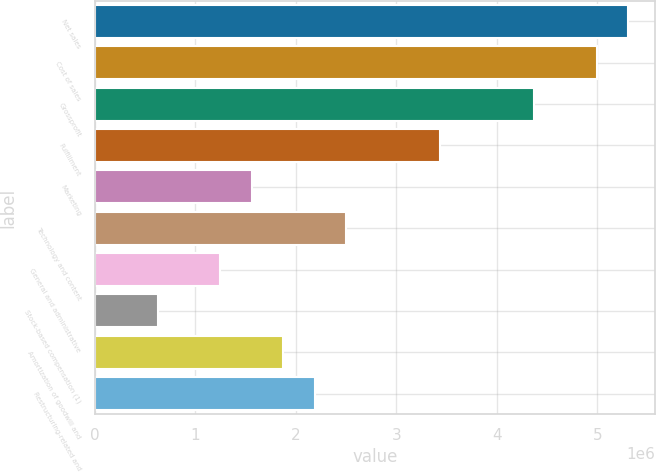Convert chart to OTSL. <chart><loc_0><loc_0><loc_500><loc_500><bar_chart><fcel>Net sales<fcel>Cost of sales<fcel>Grossprofit<fcel>Fulfillment<fcel>Marketing<fcel>Technology and content<fcel>General and administrative<fcel>Stock-based compensation (1)<fcel>Amortization of goodwill and<fcel>Restructuring-related and<nl><fcel>5.30814e+06<fcel>4.99589e+06<fcel>4.37141e+06<fcel>3.43468e+06<fcel>1.56122e+06<fcel>2.49795e+06<fcel>1.24897e+06<fcel>624488<fcel>1.87346e+06<fcel>2.1857e+06<nl></chart> 